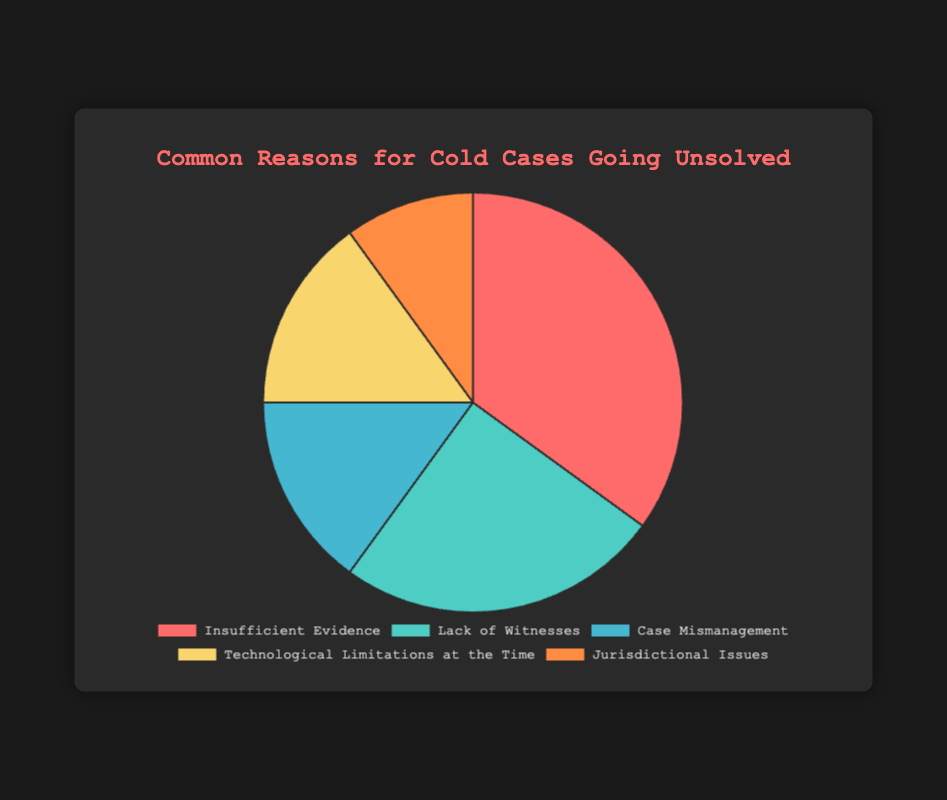What's the most common reason for cold cases going unsolved? The data shows the reasons for cold cases going unsolved, with each reason marked by a section of the pie chart. The largest section represents the most common reason, which is "Insufficient Evidence" at 35%.
Answer: Insufficient Evidence Which reason has the smallest percentage? By looking at the percentages represented in the chart, the smallest percentage is assigned to "Jurisdictional Issues" which is 10%.
Answer: Jurisdictional Issues What is the combined percentage for "Case Mismanagement" and "Technological Limitations at the Time"? Summing up the percentages for these two reasons: 15% (Case Mismanagement) + 15% (Technological Limitations at the Time) equals 30%.
Answer: 30% How much more common is "Lack of Witnesses" than "Jurisdictional Issues"? The percentage for "Lack of Witnesses" is 25%, and for "Jurisdictional Issues" it is 10%. The difference between them is 25% - 10% = 15%.
Answer: 15% Which section of the pie chart would you refer to if someone asked about issues caused by older technologies? The section labeled "Technological Limitations at the Time" represents problems caused by older technologies, and it shows 15%.
Answer: Technological Limitations at the Time Which two reasons together account for half of all unsolved cases? To find this, sum the larger sections: 35% (Insufficient Evidence) + 15% (Case Mismanagement) = 50%. Therefore, "Insufficient Evidence" and "Case Mismanagement" together account for half.
Answer: Insufficient Evidence and Case Mismanagement What is the percentage difference between "Insufficient Evidence" and "Technological Limitations at the Time"? Subtract the percentage for "Technological Limitations at the Time" (15%) from that of "Insufficient Evidence" (35%): 35% - 15% = 20%.
Answer: 20% If you combined "Lack of Witnesses" and "Jurisdictional Issues," would it surpass "Insufficient Evidence"? The combined percentage of "Lack of Witnesses" (25%) and "Jurisdictional Issues" (10%) is 25% + 10% = 35%, which is equal to "Insufficient Evidence" at 35%.
Answer: No, it equals What percentage of unsolved cases is due to "Insufficient Evidence" compared to all other reasons combined? "Insufficient Evidence" is 35%. The combined percentage of all other reasons is 100% - 35% = 65%. Therefore, "Insufficient Evidence" alone accounts for 35% compared to the 65% of all other reasons.
Answer: 35% vs. 65% In terms of visual representation, which section of the pie chart is represented in red? By examining the colors and corresponding labels, the red section represents "Insufficient Evidence," which is the largest section at 35%.
Answer: Insufficient Evidence 